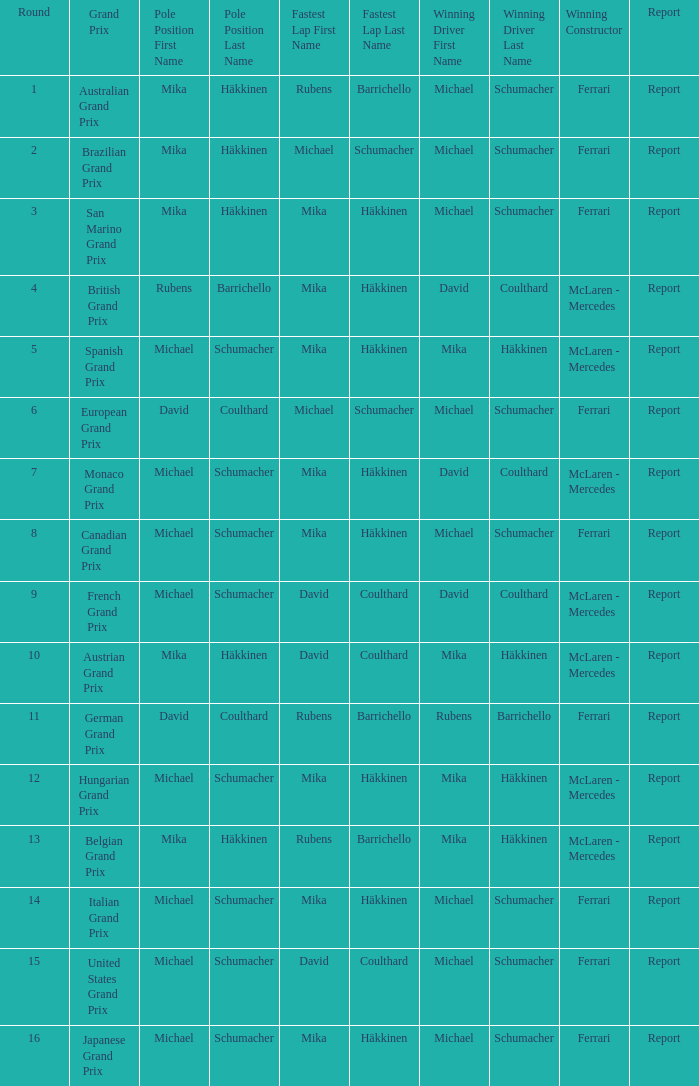Which driver recorded the speediest lap in the belgian grand prix? Rubens Barrichello. 